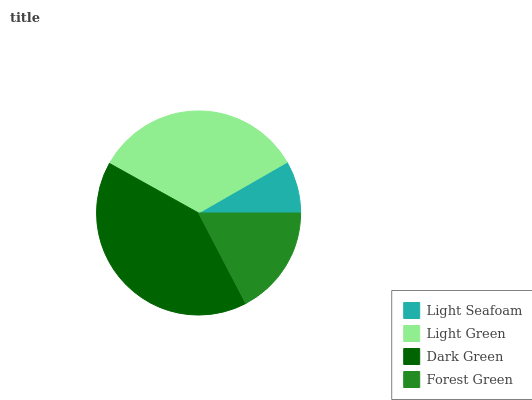Is Light Seafoam the minimum?
Answer yes or no. Yes. Is Dark Green the maximum?
Answer yes or no. Yes. Is Light Green the minimum?
Answer yes or no. No. Is Light Green the maximum?
Answer yes or no. No. Is Light Green greater than Light Seafoam?
Answer yes or no. Yes. Is Light Seafoam less than Light Green?
Answer yes or no. Yes. Is Light Seafoam greater than Light Green?
Answer yes or no. No. Is Light Green less than Light Seafoam?
Answer yes or no. No. Is Light Green the high median?
Answer yes or no. Yes. Is Forest Green the low median?
Answer yes or no. Yes. Is Dark Green the high median?
Answer yes or no. No. Is Light Green the low median?
Answer yes or no. No. 